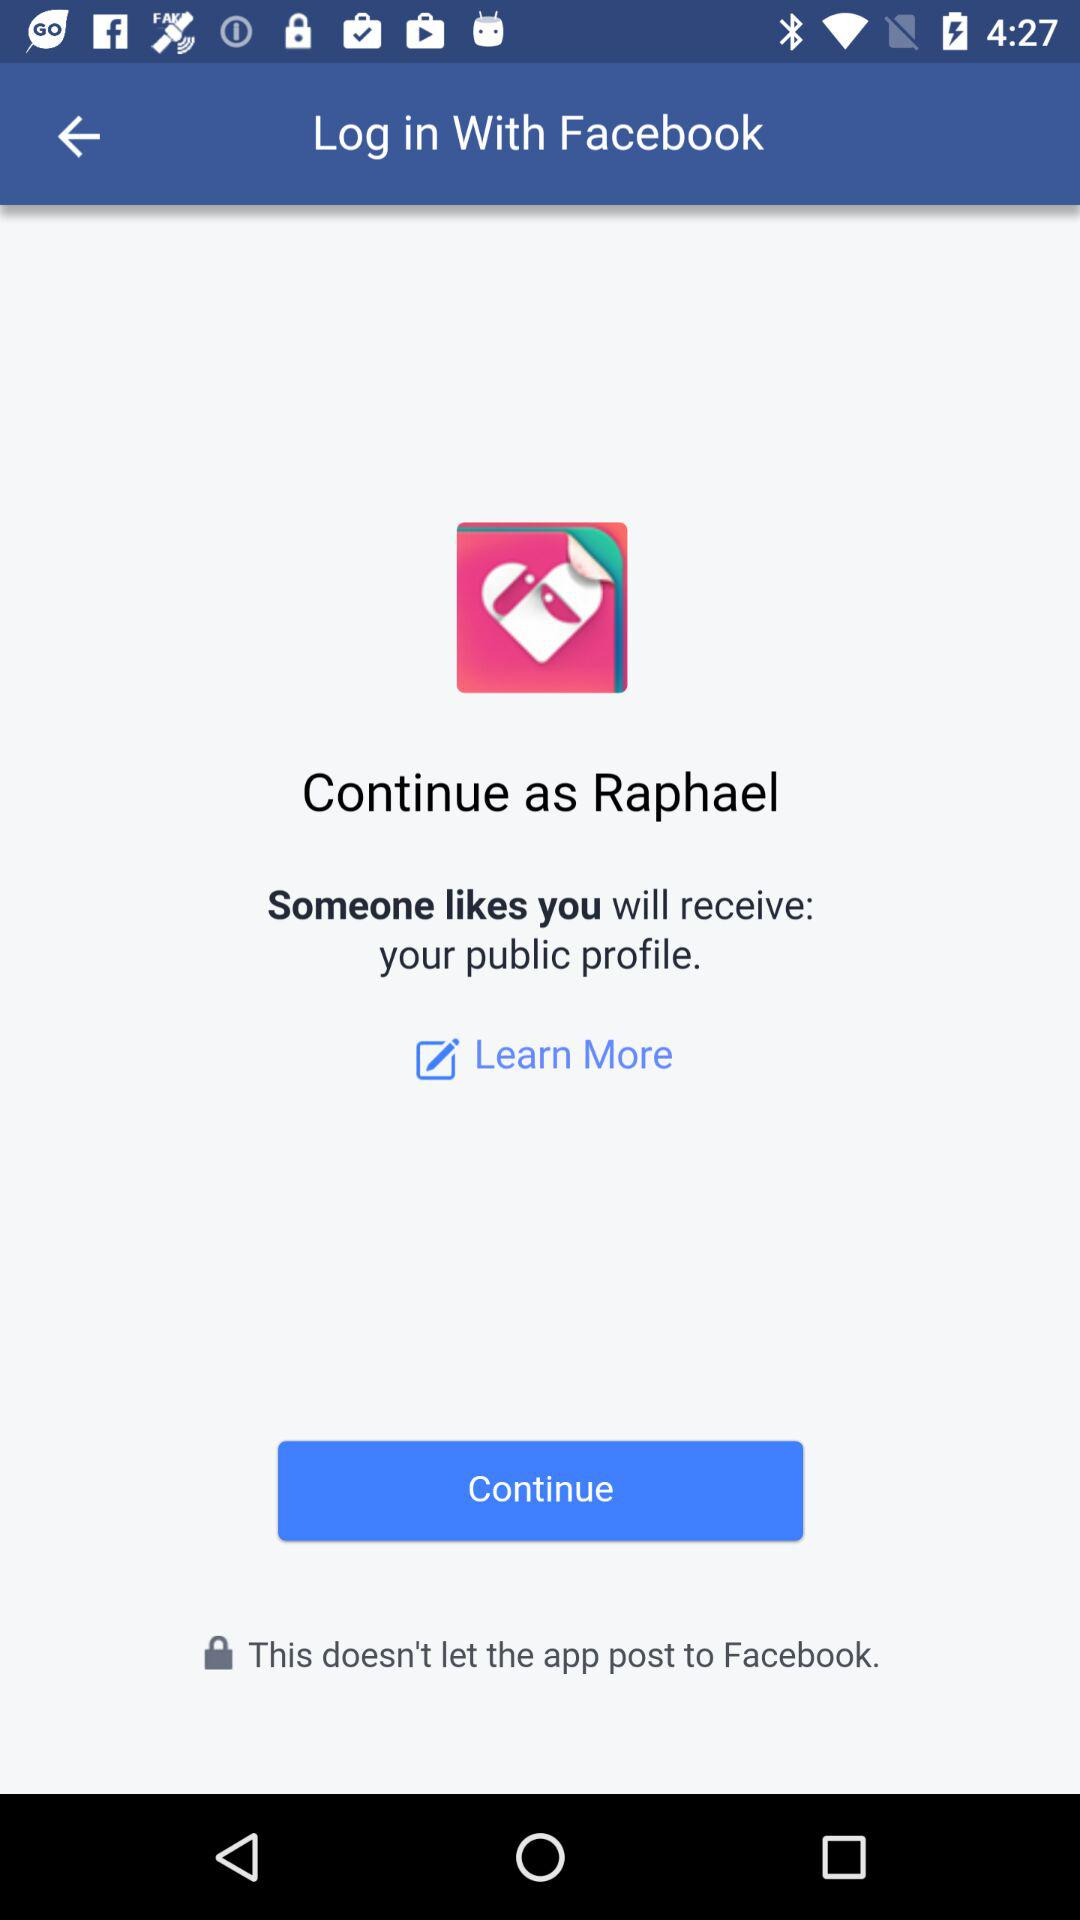What application will receive the public profile? The application "Someone likes you" will receive the public profile. 